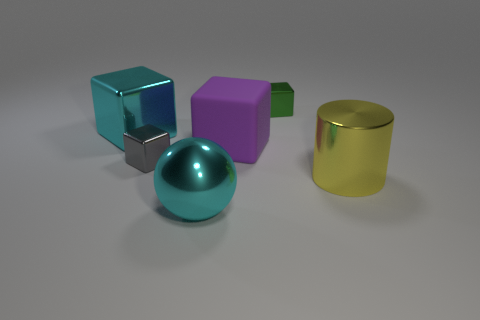Add 1 small shiny objects. How many objects exist? 7 Subtract all balls. How many objects are left? 5 Add 2 gray shiny things. How many gray shiny things are left? 3 Add 5 tiny yellow objects. How many tiny yellow objects exist? 5 Subtract 0 yellow blocks. How many objects are left? 6 Subtract all big gray blocks. Subtract all big metal objects. How many objects are left? 3 